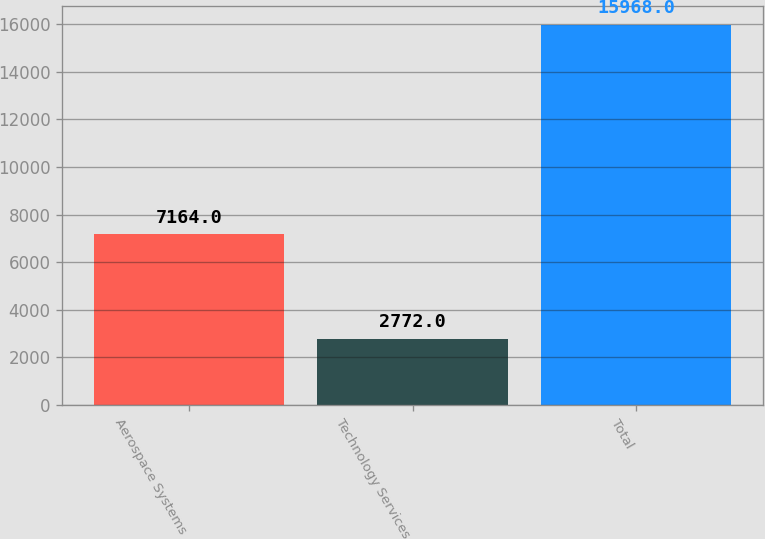Convert chart. <chart><loc_0><loc_0><loc_500><loc_500><bar_chart><fcel>Aerospace Systems<fcel>Technology Services<fcel>Total<nl><fcel>7164<fcel>2772<fcel>15968<nl></chart> 